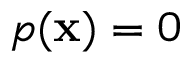Convert formula to latex. <formula><loc_0><loc_0><loc_500><loc_500>p ( x ) = 0</formula> 